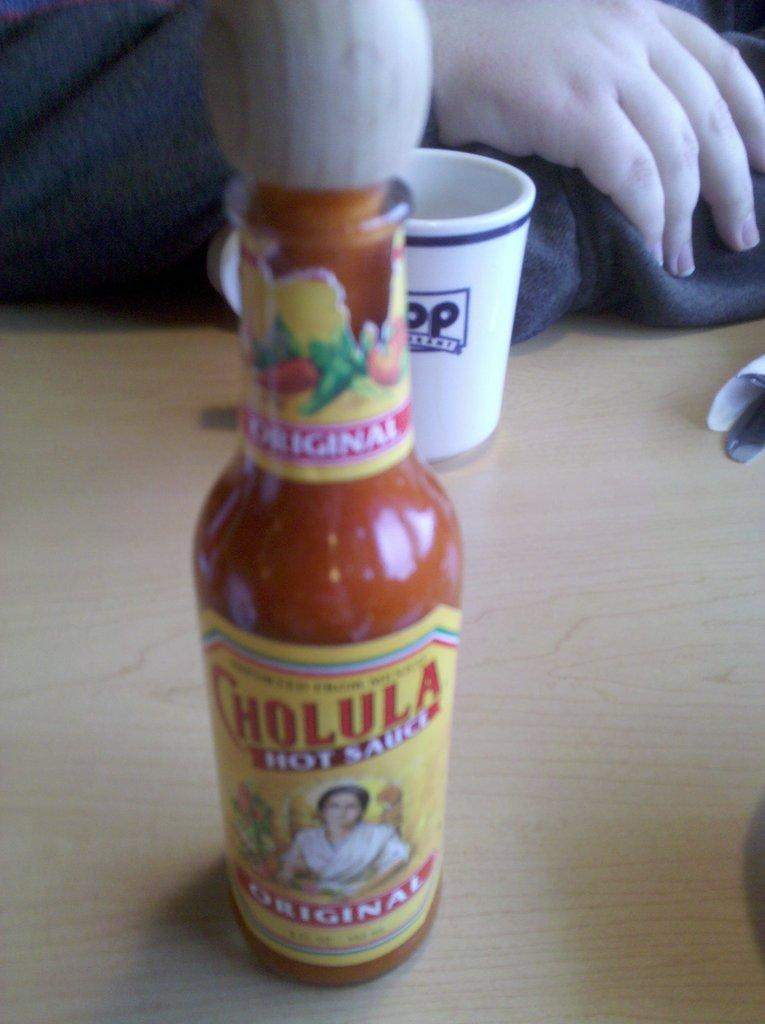What objects are on the table in the image? There is a bottle and a cup on the table in the image. What is the person in the image doing? The provided facts do not specify what the person is doing. Can you describe the person's position in the image? The person is sitting in the image. What type of pest can be seen crawling on the person's face in the image? There is no pest visible on the person's face in the image. 